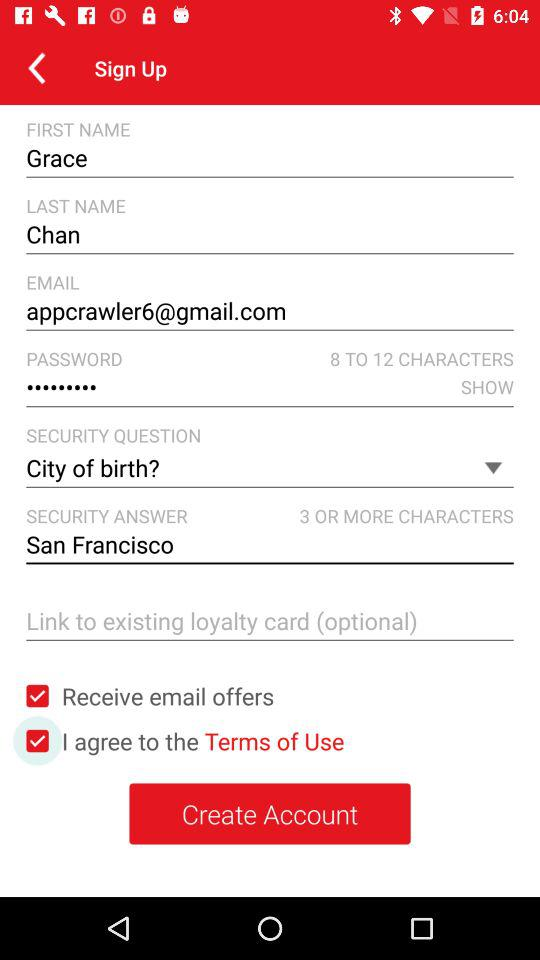What is the security answer? The security answer is "San Francisco". 